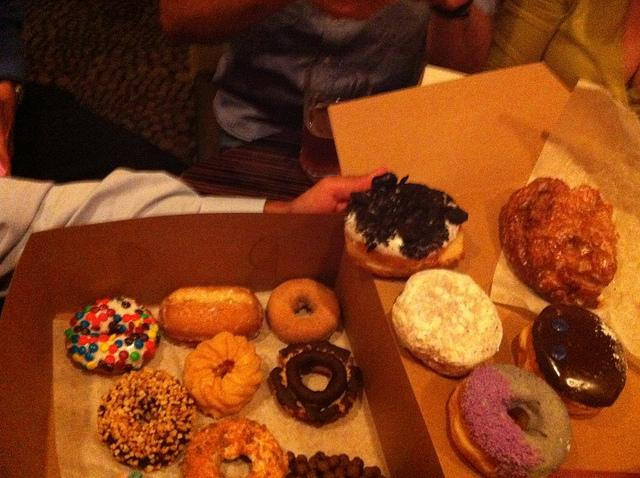What unhealthy ingredient does this food contain the most? sugar 